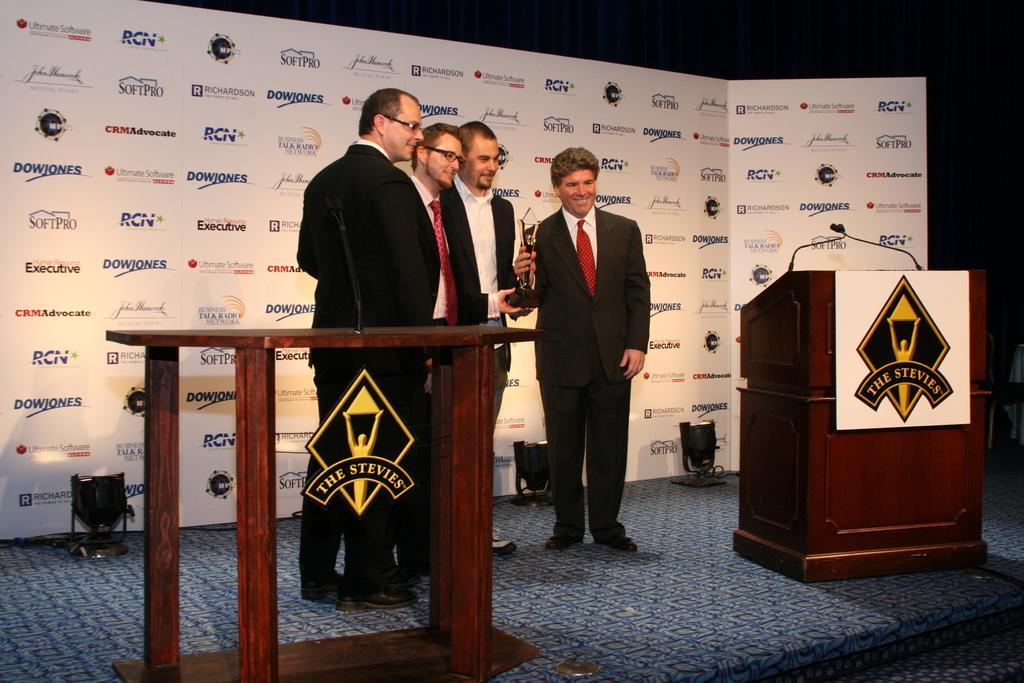Describe this image in one or two sentences. In this image there are a few people standing on the stage by holding a trophy, besides them there are two podiums with mics, behind them there is a board with sponsor names, at the bottom of the board there are lamps. 